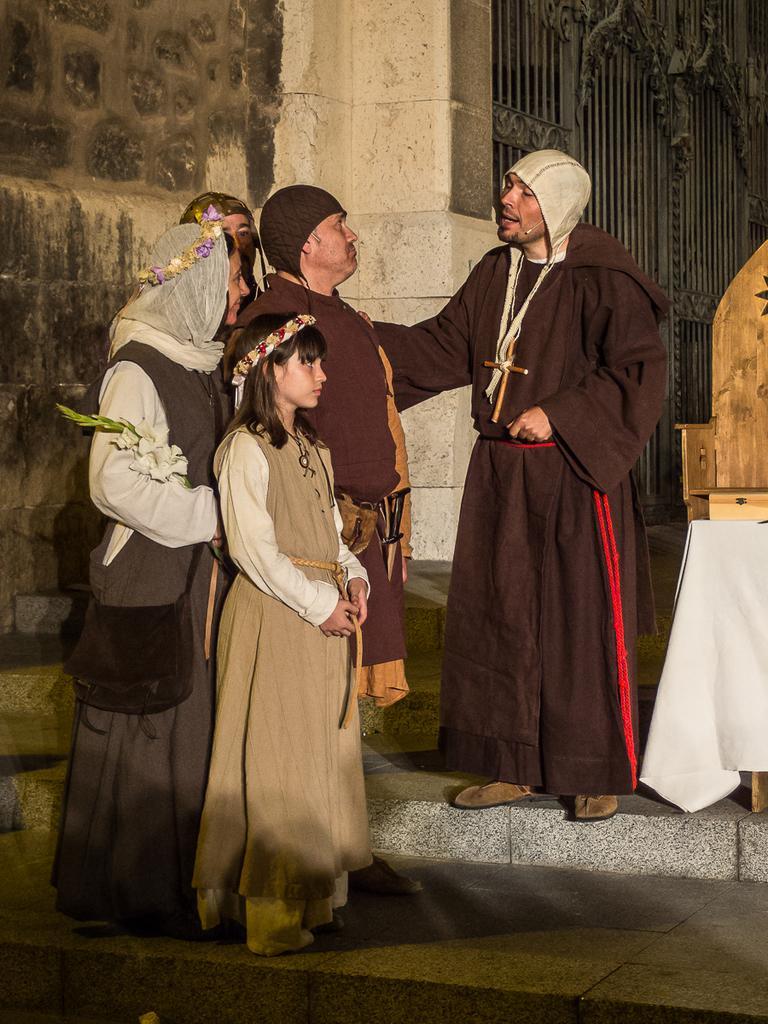Please provide a concise description of this image. In this image in the center there are a group of people who are standing, on the left side there is a wall. In the background there is a gate, at the bottom there is a floor. 